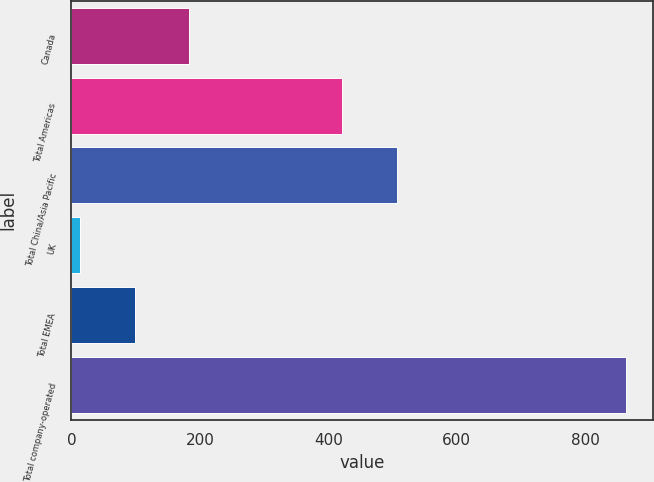<chart> <loc_0><loc_0><loc_500><loc_500><bar_chart><fcel>Canada<fcel>Total Americas<fcel>Total China/Asia Pacific<fcel>UK<fcel>Total EMEA<fcel>Total company-operated<nl><fcel>183.8<fcel>422<fcel>506.9<fcel>14<fcel>98.9<fcel>863<nl></chart> 